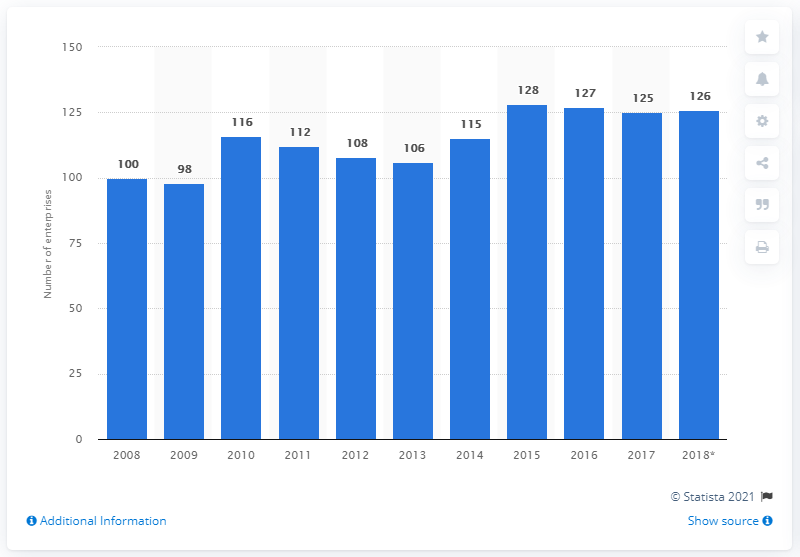Identify some key points in this picture. In 2018, there were 126 enterprises involved in the manufacture of dairy products in Hungary. 